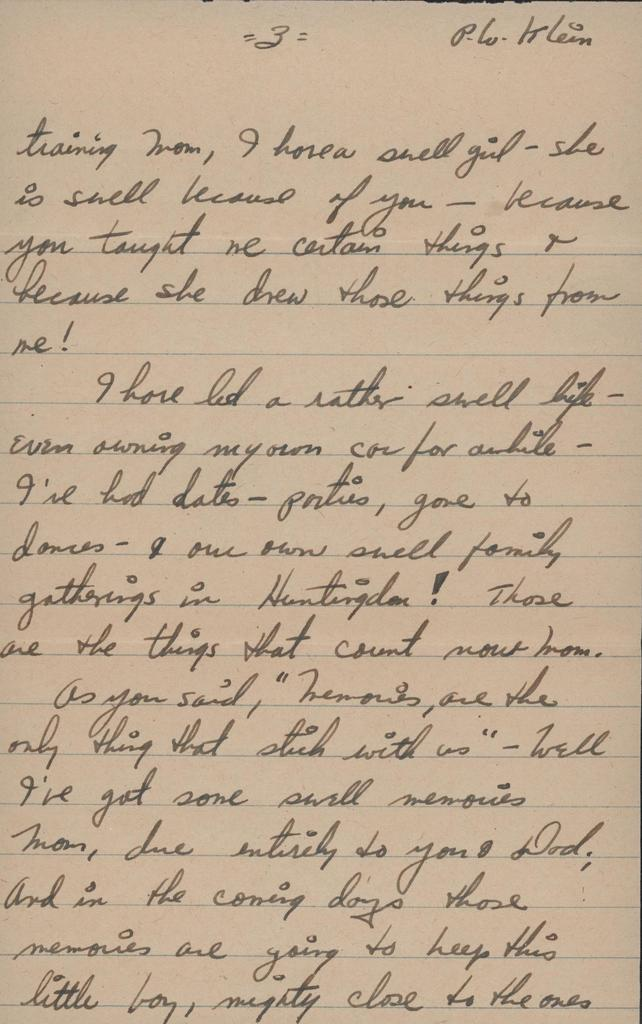<image>
Share a concise interpretation of the image provided. a paper that says 'p. w. klein' at the top 